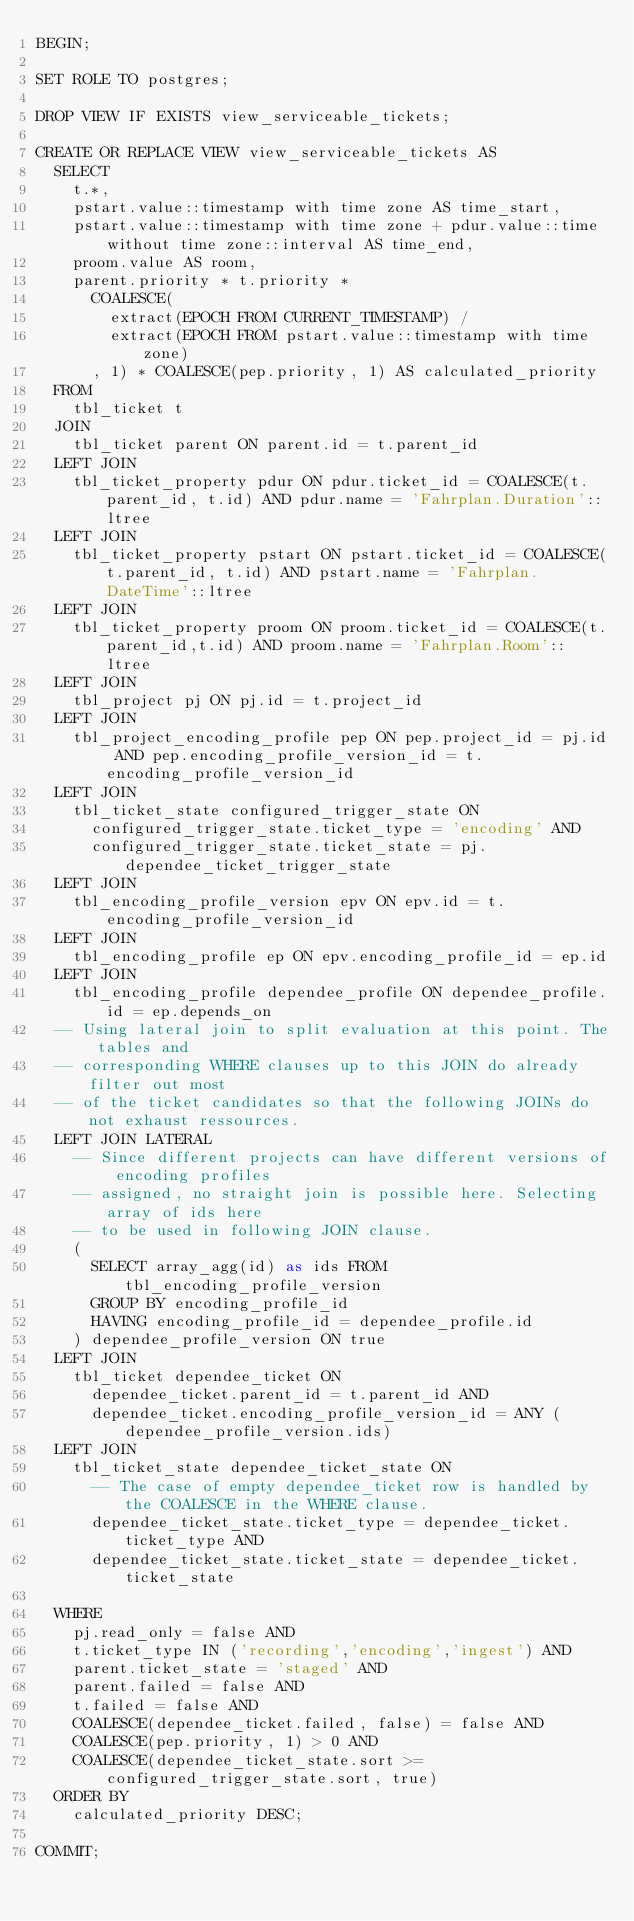<code> <loc_0><loc_0><loc_500><loc_500><_SQL_>BEGIN;

SET ROLE TO postgres;

DROP VIEW IF EXISTS view_serviceable_tickets;

CREATE OR REPLACE VIEW view_serviceable_tickets AS 
	SELECT 
		t.*,
		pstart.value::timestamp with time zone AS time_start,
		pstart.value::timestamp with time zone + pdur.value::time without time zone::interval AS time_end,
		proom.value AS room,
		parent.priority * t.priority *
			COALESCE(
				extract(EPOCH FROM CURRENT_TIMESTAMP) / 
				extract(EPOCH FROM pstart.value::timestamp with time zone)
			, 1) * COALESCE(pep.priority, 1) AS calculated_priority
	FROM
		tbl_ticket t
	JOIN
		tbl_ticket parent ON parent.id = t.parent_id
	LEFT JOIN 
		tbl_ticket_property pdur ON pdur.ticket_id = COALESCE(t.parent_id, t.id) AND pdur.name = 'Fahrplan.Duration'::ltree
	LEFT JOIN 
		tbl_ticket_property pstart ON pstart.ticket_id = COALESCE(t.parent_id, t.id) AND pstart.name = 'Fahrplan.DateTime'::ltree
	LEFT JOIN
		tbl_ticket_property proom ON proom.ticket_id = COALESCE(t.parent_id,t.id) AND proom.name = 'Fahrplan.Room'::ltree
	LEFT JOIN
		tbl_project pj ON pj.id = t.project_id
	LEFT JOIN
		tbl_project_encoding_profile pep ON pep.project_id = pj.id AND pep.encoding_profile_version_id = t.encoding_profile_version_id
	LEFT JOIN
		tbl_ticket_state configured_trigger_state ON
			configured_trigger_state.ticket_type = 'encoding' AND
			configured_trigger_state.ticket_state = pj.dependee_ticket_trigger_state
	LEFT JOIN
		tbl_encoding_profile_version epv ON epv.id = t.encoding_profile_version_id
	LEFT JOIN
		tbl_encoding_profile ep ON epv.encoding_profile_id = ep.id
	LEFT JOIN
		tbl_encoding_profile dependee_profile ON dependee_profile.id = ep.depends_on
	-- Using lateral join to split evaluation at this point. The tables and
	-- corresponding WHERE clauses up to this JOIN do already filter out most 
	-- of the ticket candidates so that the following JOINs do not exhaust ressources.
	LEFT JOIN LATERAL
		-- Since different projects can have different versions of encoding profiles
		-- assigned, no straight join is possible here. Selecting array of ids here
		-- to be used in following JOIN clause.
		(
			SELECT array_agg(id) as ids FROM tbl_encoding_profile_version
			GROUP BY encoding_profile_id
			HAVING encoding_profile_id = dependee_profile.id
		) dependee_profile_version ON true
	LEFT JOIN
		tbl_ticket dependee_ticket ON
			dependee_ticket.parent_id = t.parent_id AND
			dependee_ticket.encoding_profile_version_id = ANY (dependee_profile_version.ids)
	LEFT JOIN
		tbl_ticket_state dependee_ticket_state ON
			-- The case of empty dependee_ticket row is handled by the COALESCE in the WHERE clause.
			dependee_ticket_state.ticket_type = dependee_ticket.ticket_type AND
			dependee_ticket_state.ticket_state = dependee_ticket.ticket_state

	WHERE
		pj.read_only = false AND
		t.ticket_type IN ('recording','encoding','ingest') AND
		parent.ticket_state = 'staged' AND
		parent.failed = false AND
		t.failed = false AND
		COALESCE(dependee_ticket.failed, false) = false AND
		COALESCE(pep.priority, 1) > 0 AND
		COALESCE(dependee_ticket_state.sort >= configured_trigger_state.sort, true)
	ORDER BY
		calculated_priority DESC;

COMMIT;
</code> 